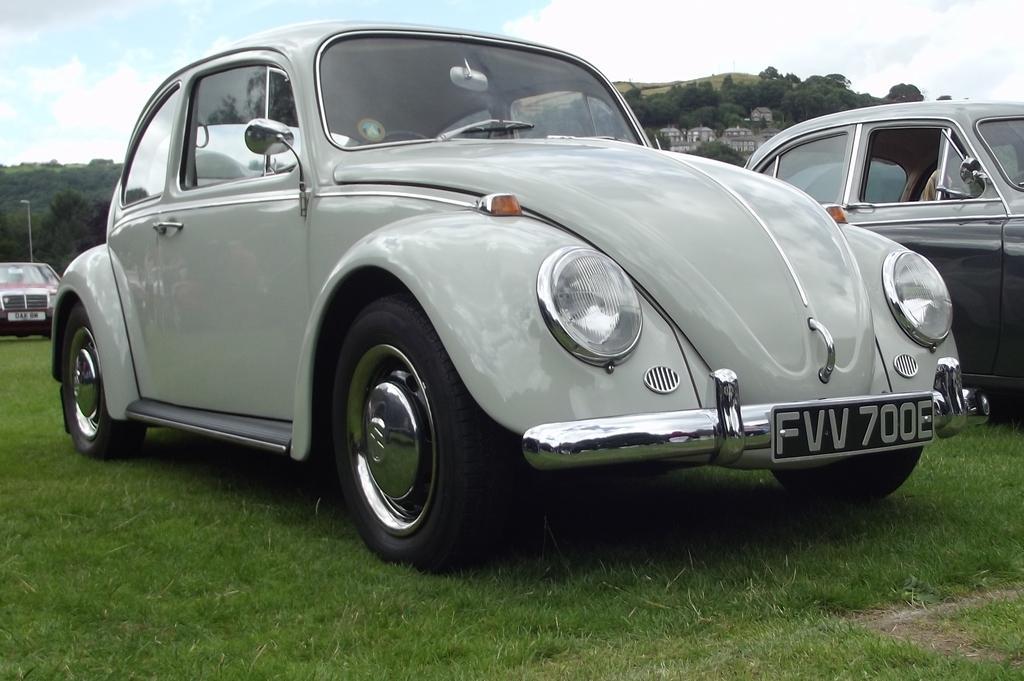Please provide a concise description of this image. In this image we can see vehicles. In the background of the image there are trees, poles, buildings and other objects. At the top of the image there is the sky. At the bottom of the image there is the grass. 